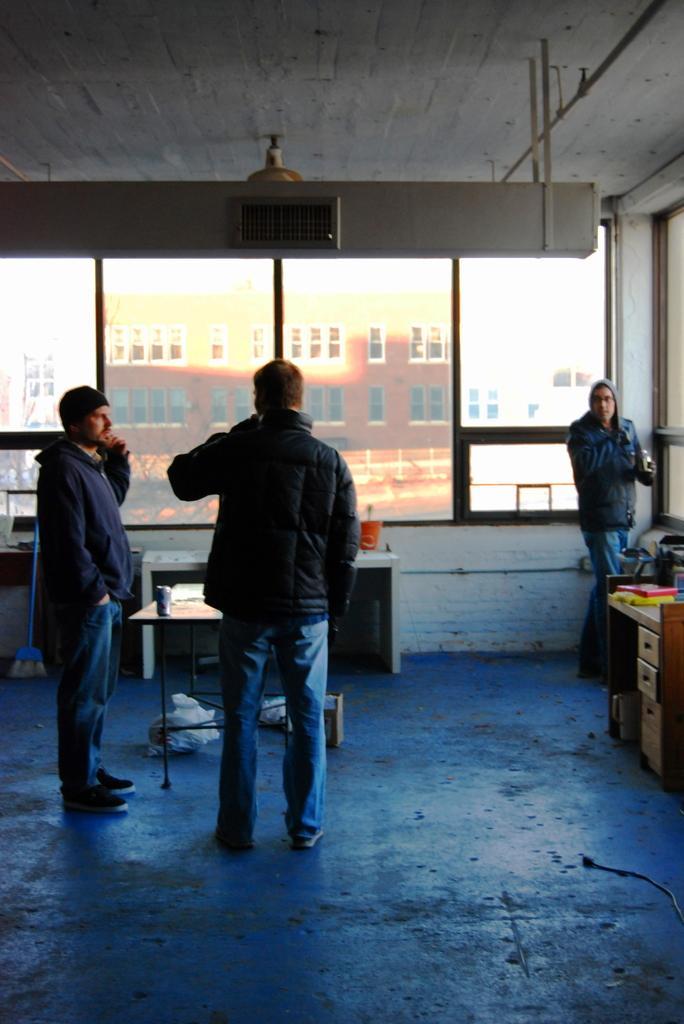Please provide a concise description of this image. In this image on the left there are two persons standing and on the right middle there is one person standing. A roof top is white in color on which lamp is mounted. And a window visible and floor is blue in color. And a table on which glass is kept. In the middle a building is visible. This image is taken inside a room. 